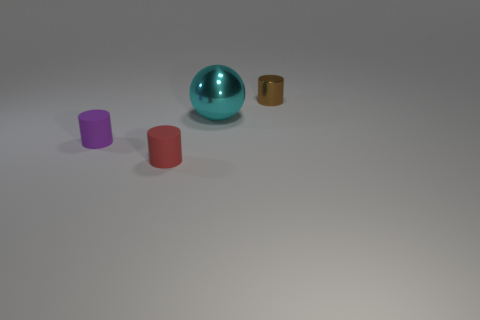Are there any other metal cylinders of the same size as the red cylinder?
Your answer should be very brief. Yes. What is the material of the small brown cylinder?
Offer a terse response. Metal. There is a small matte cylinder on the right side of the purple matte cylinder; what is its color?
Keep it short and to the point. Red. What number of big objects have the same color as the tiny metal thing?
Keep it short and to the point. 0. What number of tiny cylinders are to the right of the small purple rubber thing and in front of the cyan object?
Offer a terse response. 1. What shape is the purple rubber object that is the same size as the metal cylinder?
Ensure brevity in your answer.  Cylinder. The brown metal object has what size?
Your response must be concise. Small. There is a tiny cylinder to the right of the cylinder that is in front of the cylinder to the left of the small red matte thing; what is it made of?
Your answer should be compact. Metal. What is the color of the other object that is made of the same material as the large thing?
Ensure brevity in your answer.  Brown. How many red cylinders are in front of the small cylinder that is right of the metal thing in front of the brown thing?
Make the answer very short. 1. 